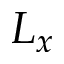<formula> <loc_0><loc_0><loc_500><loc_500>L _ { x }</formula> 